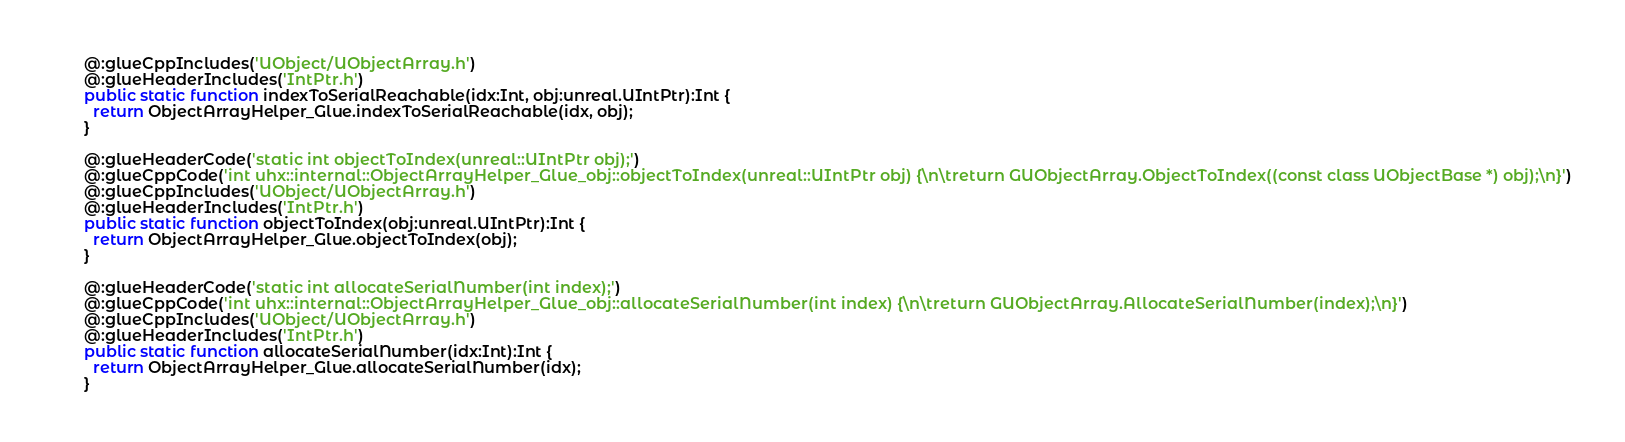Convert code to text. <code><loc_0><loc_0><loc_500><loc_500><_Haxe_>  @:glueCppIncludes('UObject/UObjectArray.h')
  @:glueHeaderIncludes('IntPtr.h')
  public static function indexToSerialReachable(idx:Int, obj:unreal.UIntPtr):Int {
    return ObjectArrayHelper_Glue.indexToSerialReachable(idx, obj);
  }

  @:glueHeaderCode('static int objectToIndex(unreal::UIntPtr obj);')
  @:glueCppCode('int uhx::internal::ObjectArrayHelper_Glue_obj::objectToIndex(unreal::UIntPtr obj) {\n\treturn GUObjectArray.ObjectToIndex((const class UObjectBase *) obj);\n}')
  @:glueCppIncludes('UObject/UObjectArray.h')
  @:glueHeaderIncludes('IntPtr.h')
  public static function objectToIndex(obj:unreal.UIntPtr):Int {
    return ObjectArrayHelper_Glue.objectToIndex(obj);
  }

  @:glueHeaderCode('static int allocateSerialNumber(int index);')
  @:glueCppCode('int uhx::internal::ObjectArrayHelper_Glue_obj::allocateSerialNumber(int index) {\n\treturn GUObjectArray.AllocateSerialNumber(index);\n}')
  @:glueCppIncludes('UObject/UObjectArray.h')
  @:glueHeaderIncludes('IntPtr.h')
  public static function allocateSerialNumber(idx:Int):Int {
    return ObjectArrayHelper_Glue.allocateSerialNumber(idx);
  }
</code> 